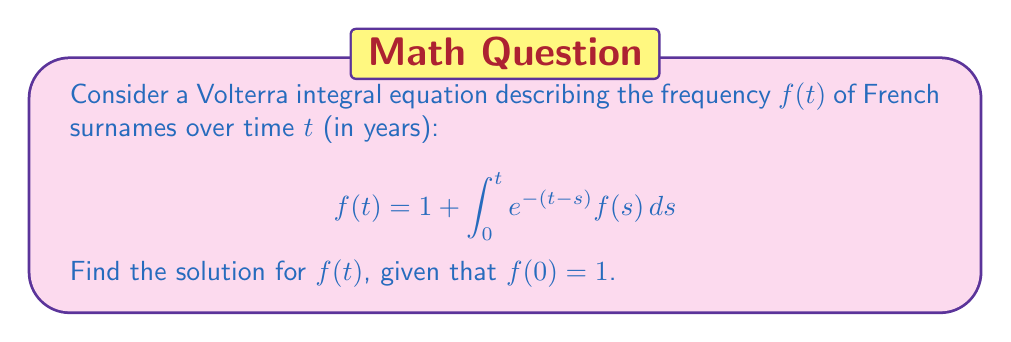Can you answer this question? Let's solve this Volterra integral equation step-by-step:

1) First, we differentiate both sides of the equation with respect to $t$:

   $$\frac{d}{dt}f(t) = \frac{d}{dt}\left(1 + \int_0^t e^{-(t-s)} f(s) ds\right)$$

2) Using the Leibniz rule for differentiation under the integral sign:

   $$f'(t) = e^{-(t-t)}f(t) - \int_0^t \frac{d}{dt}(e^{-(t-s)}) f(s) ds$$

3) Simplify:

   $$f'(t) = f(t) + \int_0^t e^{-(t-s)} f(s) ds$$

4) Substitute the original equation for the integral term:

   $$f'(t) = f(t) + (f(t) - 1)$$

5) Simplify:

   $$f'(t) = 2f(t) - 1$$

6) This is a first-order linear differential equation. Rearrange:

   $$f'(t) - 2f(t) = -1$$

7) The general solution to this equation is:

   $$f(t) = Ce^{2t} + \frac{1}{2}$$

8) Use the initial condition $f(0) = 1$ to find $C$:

   $$1 = C + \frac{1}{2}$$
   $$C = \frac{1}{2}$$

9) Therefore, the final solution is:

   $$f(t) = \frac{1}{2}e^{2t} + \frac{1}{2}$$

This solution represents the frequency of French surnames over time.
Answer: $f(t) = \frac{1}{2}e^{2t} + \frac{1}{2}$ 